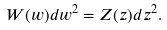<formula> <loc_0><loc_0><loc_500><loc_500>W ( w ) d w ^ { 2 } = Z ( z ) d z ^ { 2 } .</formula> 